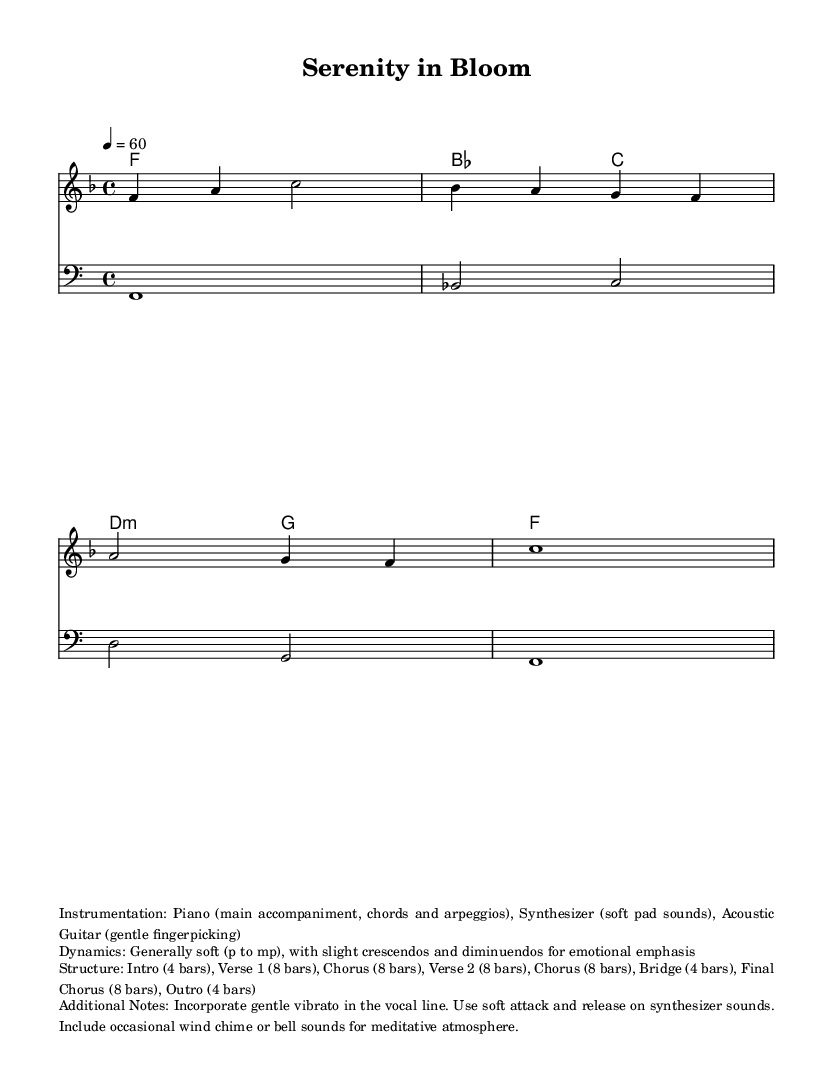What is the key signature of this music? The key signature indicates F major, which has one flat (B flat). This can be identified by looking at the key signature part at the beginning of the sheet music.
Answer: F major What is the time signature of the piece? The time signature is 4/4, which means there are four beats in each measure, and the quarter note gets one beat. This is indicated at the beginning of the sheet music right after the key signature.
Answer: 4/4 What is the tempo marking for this piece? The tempo marking is quarter note equals 60, indicating a slow and steady pace. This information is given in the tempo section at the beginning.
Answer: 60 How many bars are there in the verse section? The verse section comprises eight bars as indicated in the structure description and notation. Each section is counted based on the measures shown in the score.
Answer: 8 What instruments are mentioned for the accompaniment? The instruments mentioned include Piano, Synthesizer, and Acoustic Guitar, as explicitly stated in the instrumentation section.
Answer: Piano, Synthesizer, Acoustic Guitar What dynamics are primarily used throughout the piece? The dynamics are generally soft, ranging from piano to mezzo-piano, with slight crescendos and diminuendos for emotional emphasis. This is noted in the dynamics section of the additional notes.
Answer: Soft (p to mp) What kind of atmosphere is intended for the piece? The atmosphere is meant to be meditative, enhanced with gentle vibrato and soft synthesizer sounds, as described in the additional notes for creating a calming effect.
Answer: Meditative atmosphere 